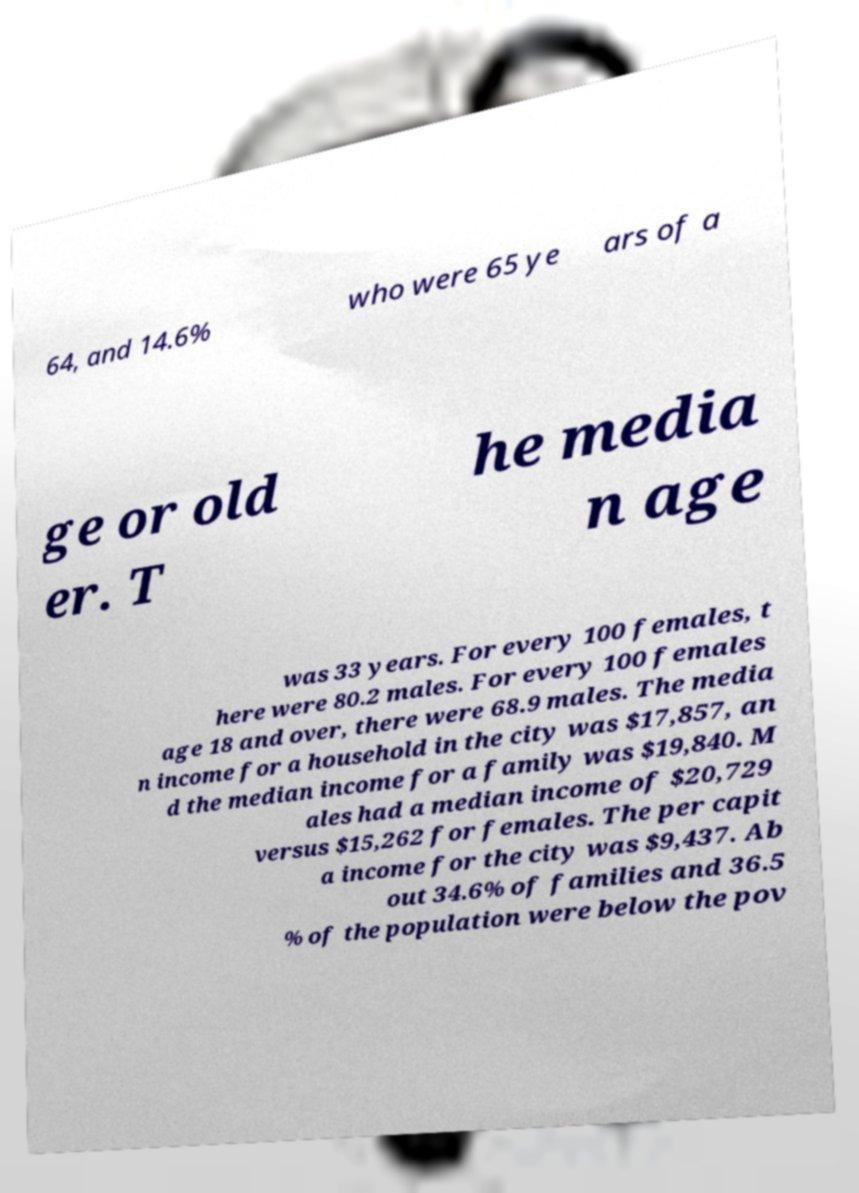I need the written content from this picture converted into text. Can you do that? 64, and 14.6% who were 65 ye ars of a ge or old er. T he media n age was 33 years. For every 100 females, t here were 80.2 males. For every 100 females age 18 and over, there were 68.9 males. The media n income for a household in the city was $17,857, an d the median income for a family was $19,840. M ales had a median income of $20,729 versus $15,262 for females. The per capit a income for the city was $9,437. Ab out 34.6% of families and 36.5 % of the population were below the pov 